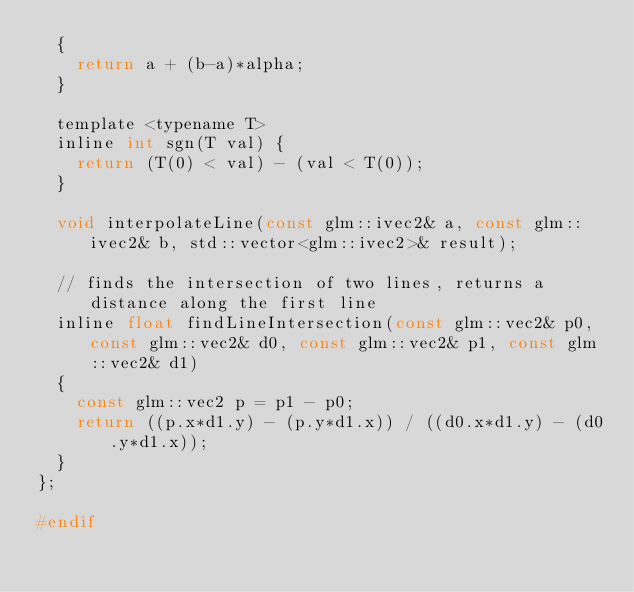<code> <loc_0><loc_0><loc_500><loc_500><_C_>  {
    return a + (b-a)*alpha;
  }

  template <typename T>
  inline int sgn(T val) {
    return (T(0) < val) - (val < T(0));
  }

  void interpolateLine(const glm::ivec2& a, const glm::ivec2& b, std::vector<glm::ivec2>& result);

  // finds the intersection of two lines, returns a distance along the first line
  inline float findLineIntersection(const glm::vec2& p0, const glm::vec2& d0, const glm::vec2& p1, const glm::vec2& d1)
  {
    const glm::vec2 p = p1 - p0;
    return ((p.x*d1.y) - (p.y*d1.x)) / ((d0.x*d1.y) - (d0.y*d1.x));
  }
};

#endif
</code> 